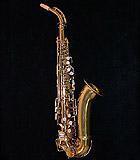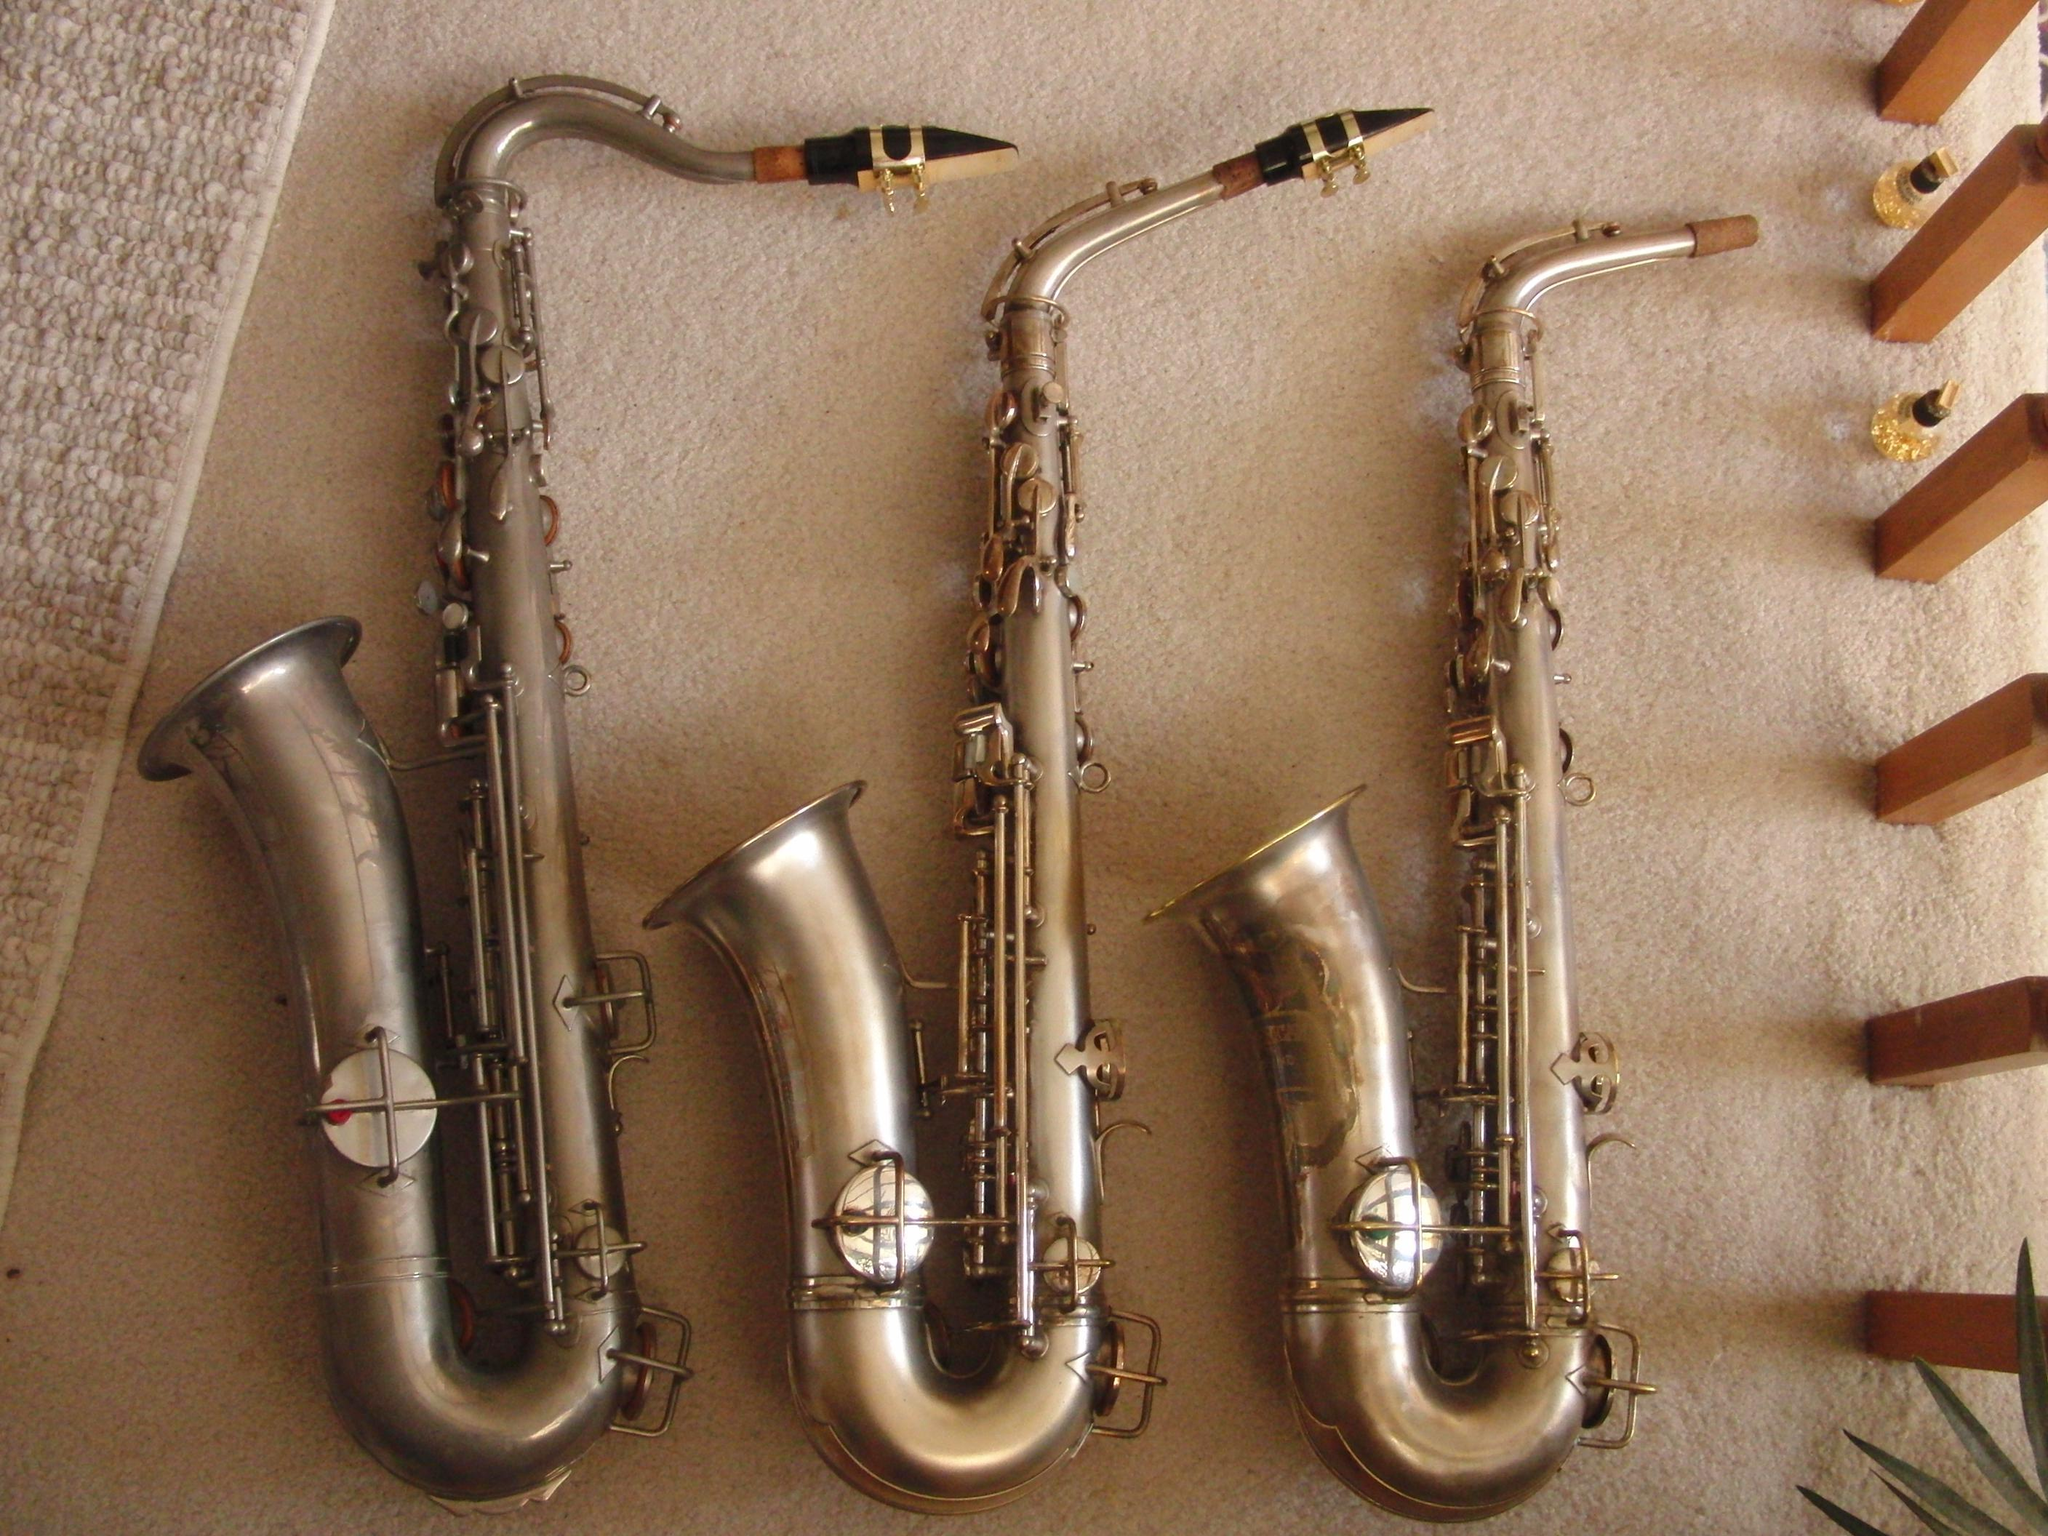The first image is the image on the left, the second image is the image on the right. Assess this claim about the two images: "At least one image contains exactly three saxophones, and no image shows a saxophone broken down into parts.". Correct or not? Answer yes or no. Yes. 